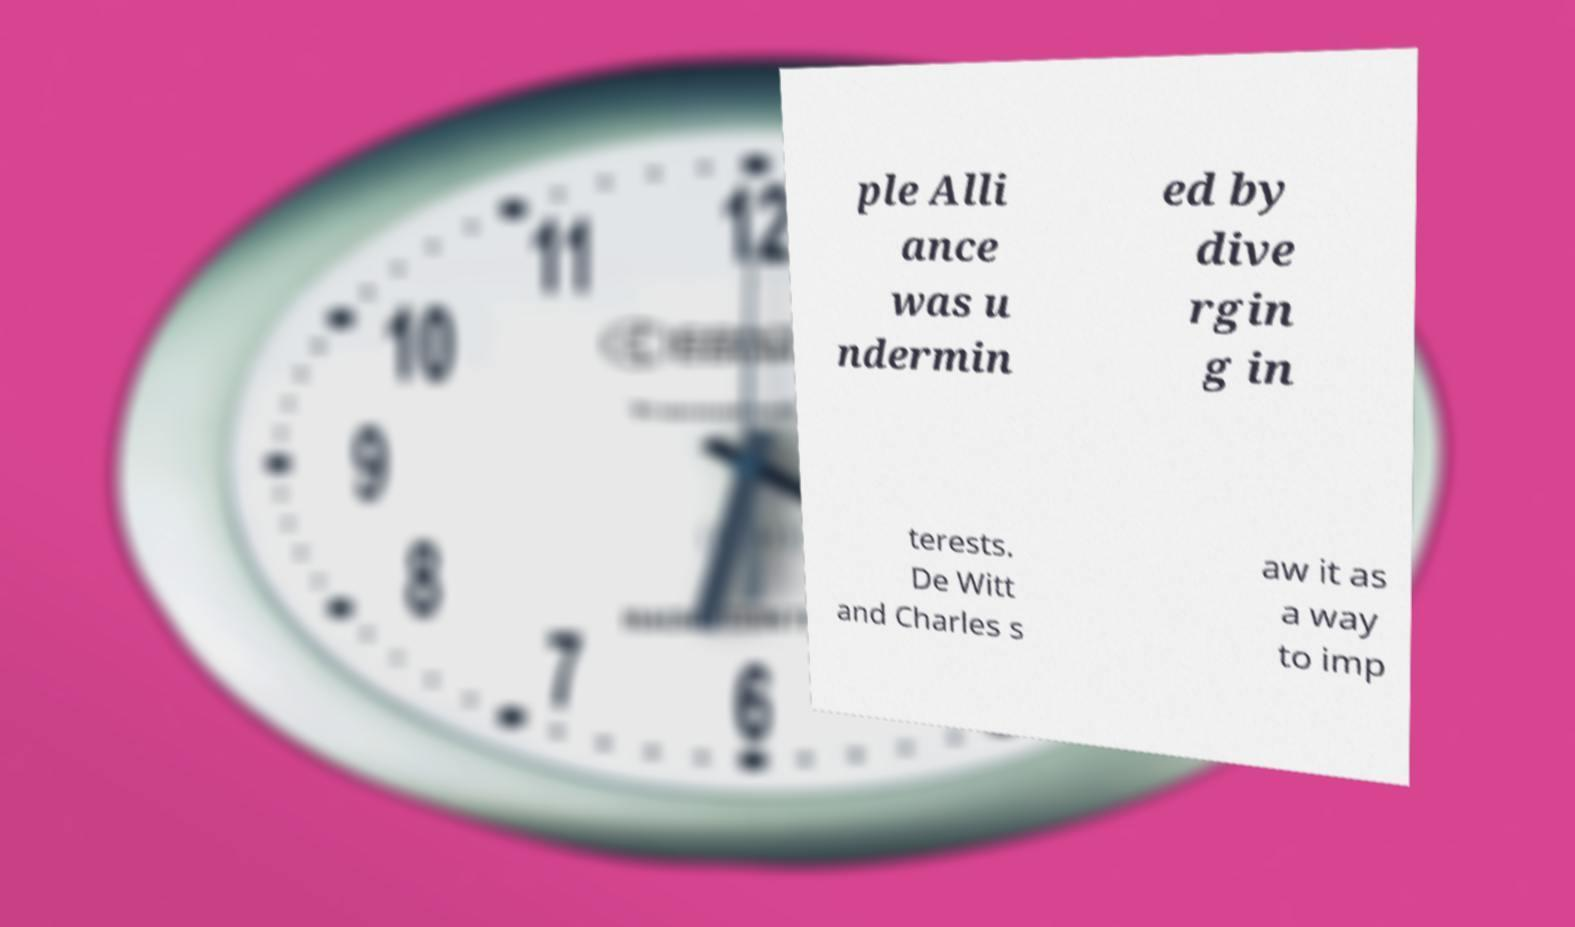Please read and relay the text visible in this image. What does it say? ple Alli ance was u ndermin ed by dive rgin g in terests. De Witt and Charles s aw it as a way to imp 